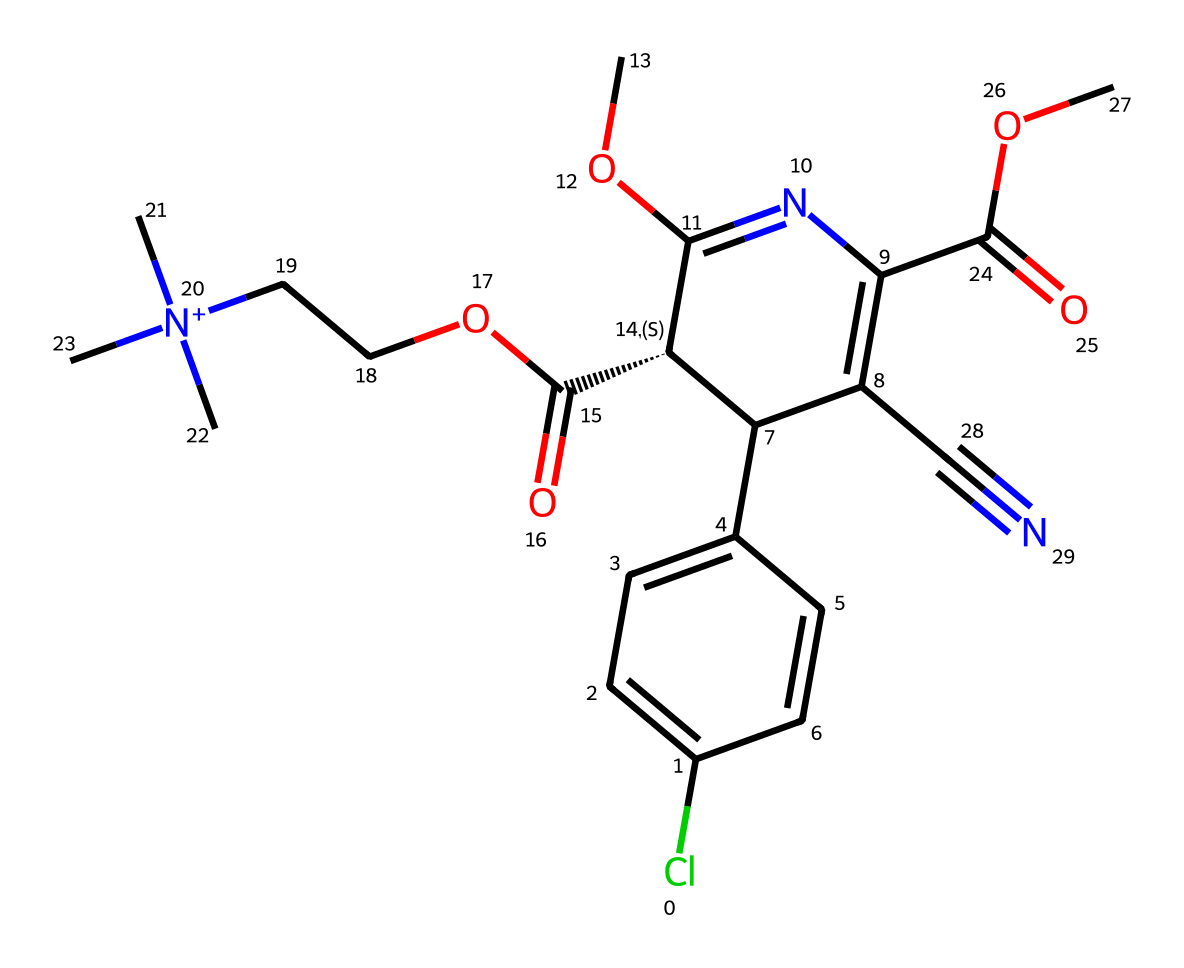What is the main pharmaceutical purpose of this compound? The compound is amlodipine, which is primarily used to treat hypertension (high blood pressure) and angina (chest pain).
Answer: hypertension How many stereocenters are present in this compound? By examining the chemical structure, there is one chiral center indicated by the notation [C@H], meaning there is one stereocenter.
Answer: one What type of geometric isomerism is observed in this compound? The compound demonstrates E/Z isomerism due to the presence of double bonds that have substituents causing potential geometric differences.
Answer: E/Z isomerism How many ethyl groups are present in the structure? The structure contains two ethyl groups associated with the nitrogen atom and the side chain, observed as -N+(C)(C)- and the two -OCC- parts in the SMILES.
Answer: two Does this compound contain a cyano group? A cyano group (-C≡N) is represented in the structure by the part "C#N" indicating the presence of a carbon triple-bonded to a nitrogen.
Answer: yes What is the role of the chlorine substituent in the compound? The chlorine substituent can influence the lipophilicity and profile of the medication, potentially enhancing its pharmacological effect.
Answer: pharmacological effect 